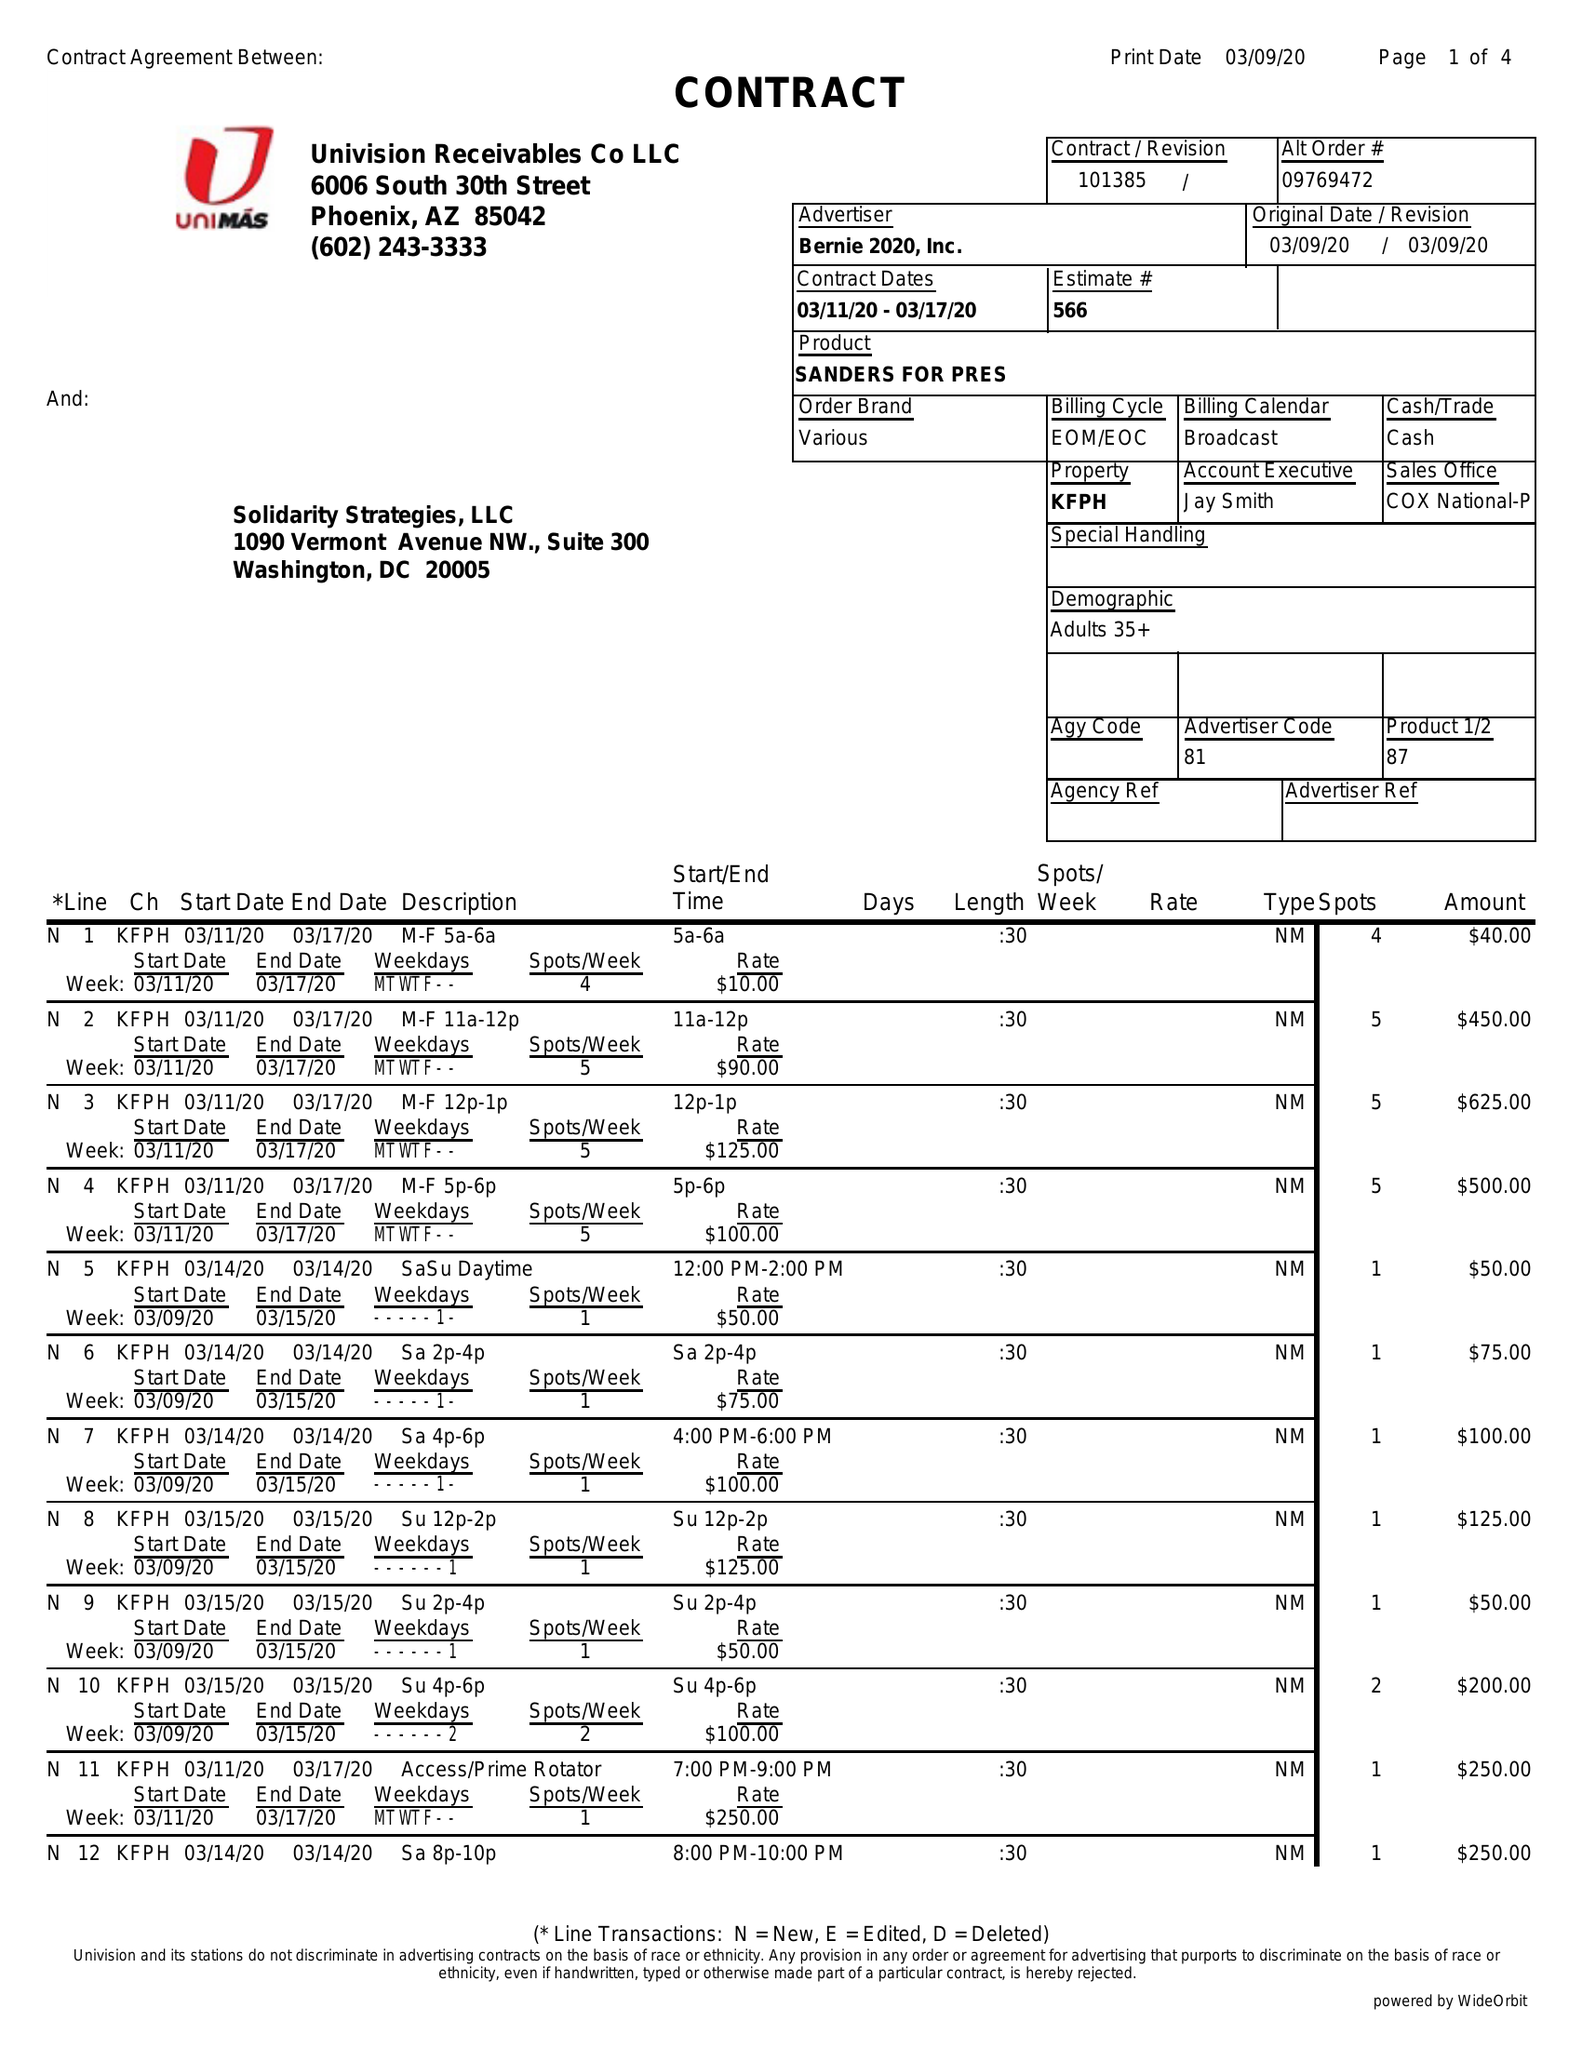What is the value for the contract_num?
Answer the question using a single word or phrase. 101385 